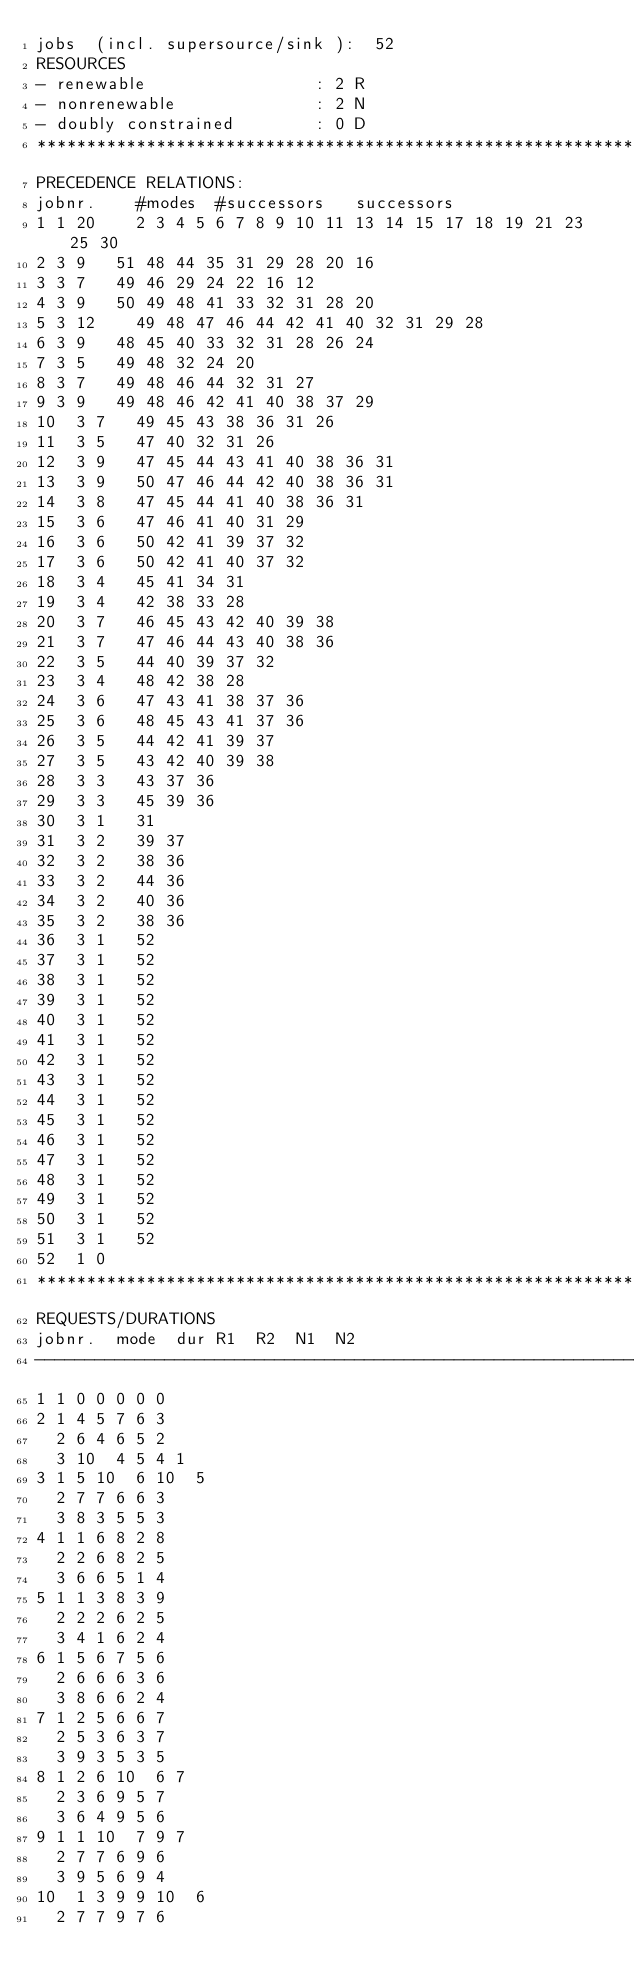<code> <loc_0><loc_0><loc_500><loc_500><_ObjectiveC_>jobs  (incl. supersource/sink ):	52
RESOURCES
- renewable                 : 2 R
- nonrenewable              : 2 N
- doubly constrained        : 0 D
************************************************************************
PRECEDENCE RELATIONS:
jobnr.    #modes  #successors   successors
1	1	20		2 3 4 5 6 7 8 9 10 11 13 14 15 17 18 19 21 23 25 30 
2	3	9		51 48 44 35 31 29 28 20 16 
3	3	7		49 46 29 24 22 16 12 
4	3	9		50 49 48 41 33 32 31 28 20 
5	3	12		49 48 47 46 44 42 41 40 32 31 29 28 
6	3	9		48 45 40 33 32 31 28 26 24 
7	3	5		49 48 32 24 20 
8	3	7		49 48 46 44 32 31 27 
9	3	9		49 48 46 42 41 40 38 37 29 
10	3	7		49 45 43 38 36 31 26 
11	3	5		47 40 32 31 26 
12	3	9		47 45 44 43 41 40 38 36 31 
13	3	9		50 47 46 44 42 40 38 36 31 
14	3	8		47 45 44 41 40 38 36 31 
15	3	6		47 46 41 40 31 29 
16	3	6		50 42 41 39 37 32 
17	3	6		50 42 41 40 37 32 
18	3	4		45 41 34 31 
19	3	4		42 38 33 28 
20	3	7		46 45 43 42 40 39 38 
21	3	7		47 46 44 43 40 38 36 
22	3	5		44 40 39 37 32 
23	3	4		48 42 38 28 
24	3	6		47 43 41 38 37 36 
25	3	6		48 45 43 41 37 36 
26	3	5		44 42 41 39 37 
27	3	5		43 42 40 39 38 
28	3	3		43 37 36 
29	3	3		45 39 36 
30	3	1		31 
31	3	2		39 37 
32	3	2		38 36 
33	3	2		44 36 
34	3	2		40 36 
35	3	2		38 36 
36	3	1		52 
37	3	1		52 
38	3	1		52 
39	3	1		52 
40	3	1		52 
41	3	1		52 
42	3	1		52 
43	3	1		52 
44	3	1		52 
45	3	1		52 
46	3	1		52 
47	3	1		52 
48	3	1		52 
49	3	1		52 
50	3	1		52 
51	3	1		52 
52	1	0		
************************************************************************
REQUESTS/DURATIONS
jobnr.	mode	dur	R1	R2	N1	N2	
------------------------------------------------------------------------
1	1	0	0	0	0	0	
2	1	4	5	7	6	3	
	2	6	4	6	5	2	
	3	10	4	5	4	1	
3	1	5	10	6	10	5	
	2	7	7	6	6	3	
	3	8	3	5	5	3	
4	1	1	6	8	2	8	
	2	2	6	8	2	5	
	3	6	6	5	1	4	
5	1	1	3	8	3	9	
	2	2	2	6	2	5	
	3	4	1	6	2	4	
6	1	5	6	7	5	6	
	2	6	6	6	3	6	
	3	8	6	6	2	4	
7	1	2	5	6	6	7	
	2	5	3	6	3	7	
	3	9	3	5	3	5	
8	1	2	6	10	6	7	
	2	3	6	9	5	7	
	3	6	4	9	5	6	
9	1	1	10	7	9	7	
	2	7	7	6	9	6	
	3	9	5	6	9	4	
10	1	3	9	9	10	6	
	2	7	7	9	7	6	</code> 